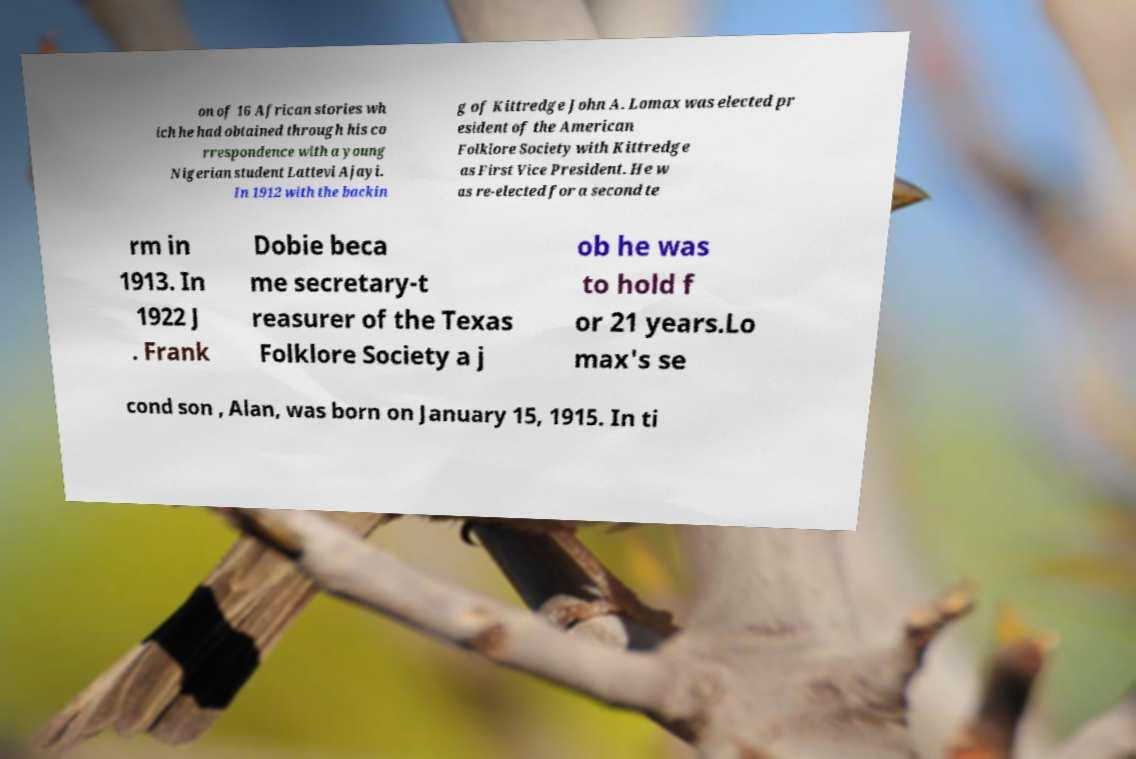Can you accurately transcribe the text from the provided image for me? on of 16 African stories wh ich he had obtained through his co rrespondence with a young Nigerian student Lattevi Ajayi. In 1912 with the backin g of Kittredge John A. Lomax was elected pr esident of the American Folklore Society with Kittredge as First Vice President. He w as re-elected for a second te rm in 1913. In 1922 J . Frank Dobie beca me secretary-t reasurer of the Texas Folklore Society a j ob he was to hold f or 21 years.Lo max's se cond son , Alan, was born on January 15, 1915. In ti 